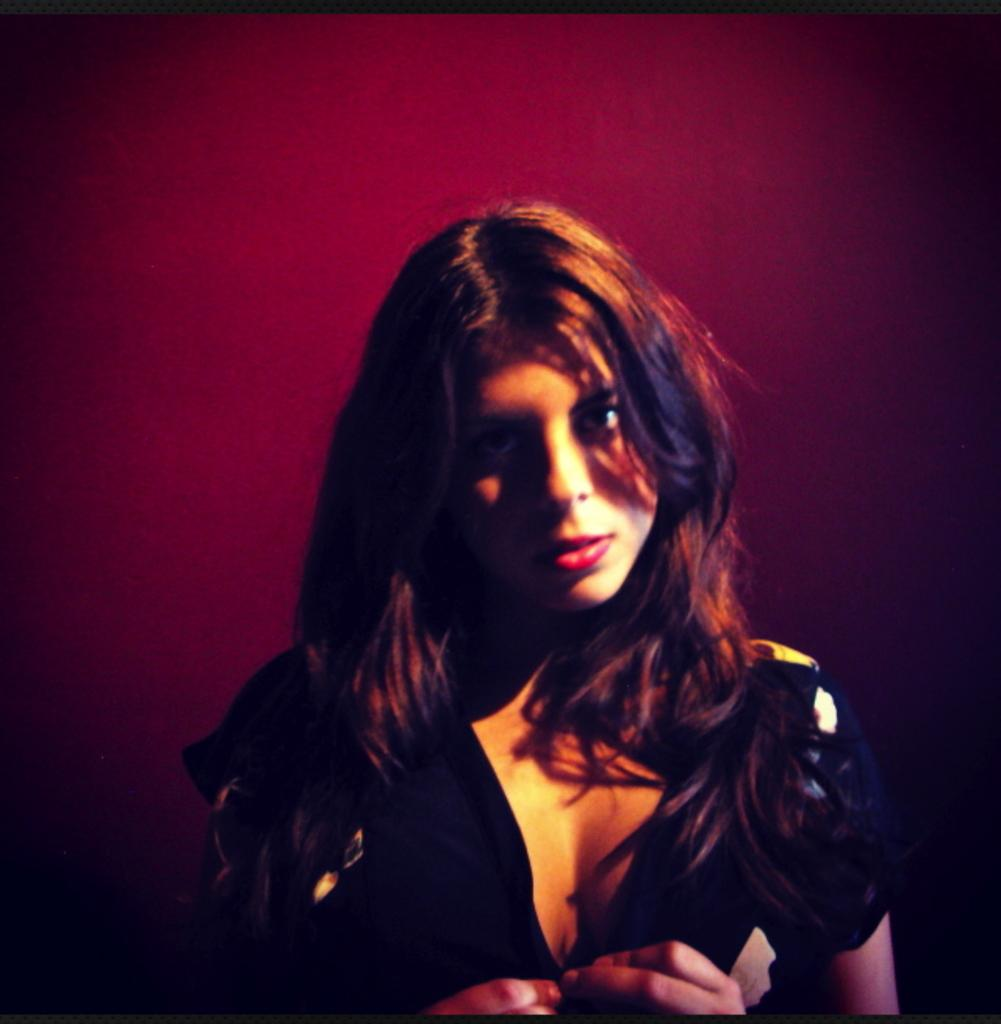Who is present in the image? There is a woman in the image. What is the woman wearing? The woman is wearing a black dress. What can be seen behind the woman in the image? The background of the image is plain. What type of appliance is the woman using in the image? There is no appliance present in the image; the woman is simply standing there. How many cents can be seen in the image? There are no cents visible in the image. 